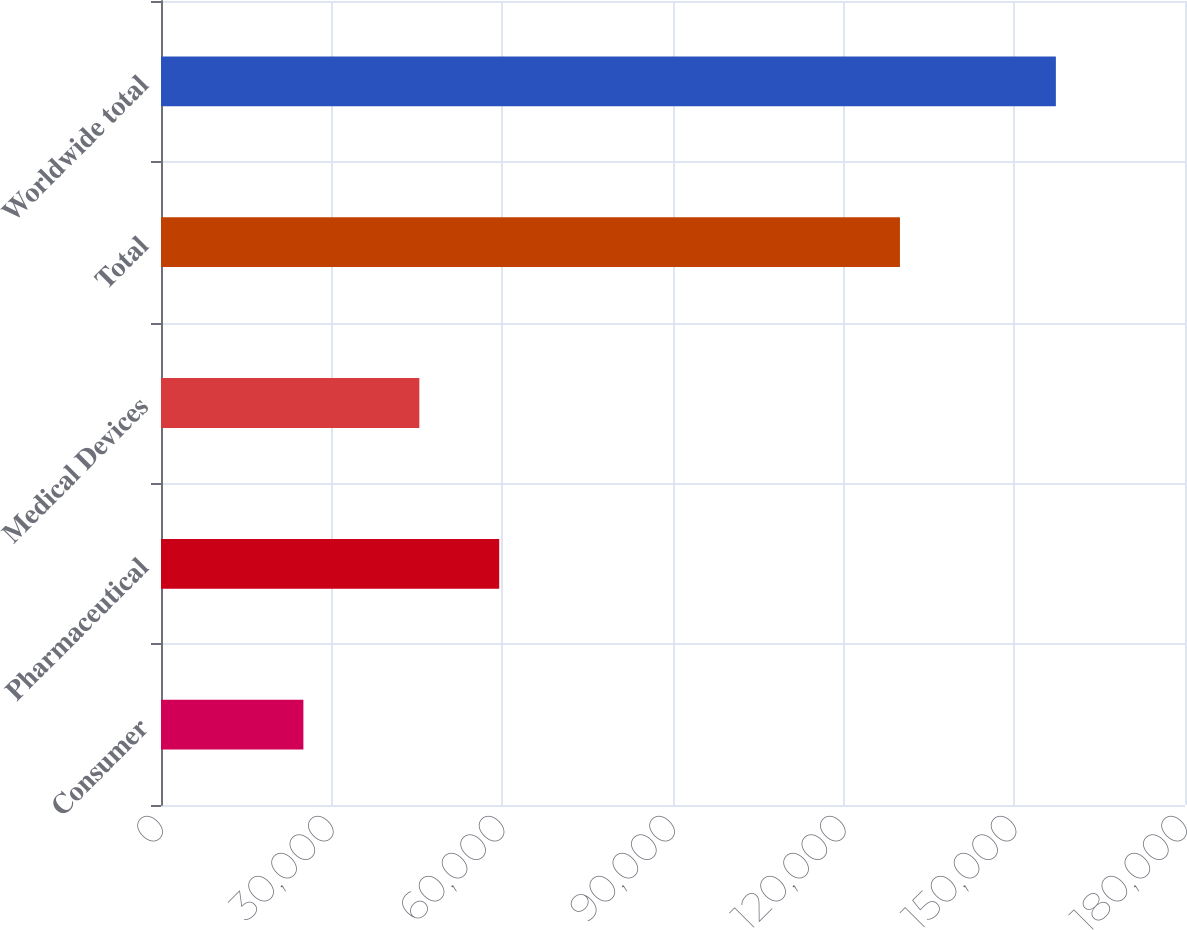Convert chart to OTSL. <chart><loc_0><loc_0><loc_500><loc_500><bar_chart><fcel>Consumer<fcel>Pharmaceutical<fcel>Medical Devices<fcel>Total<fcel>Worldwide total<nl><fcel>25030<fcel>59450<fcel>45413<fcel>129893<fcel>157303<nl></chart> 